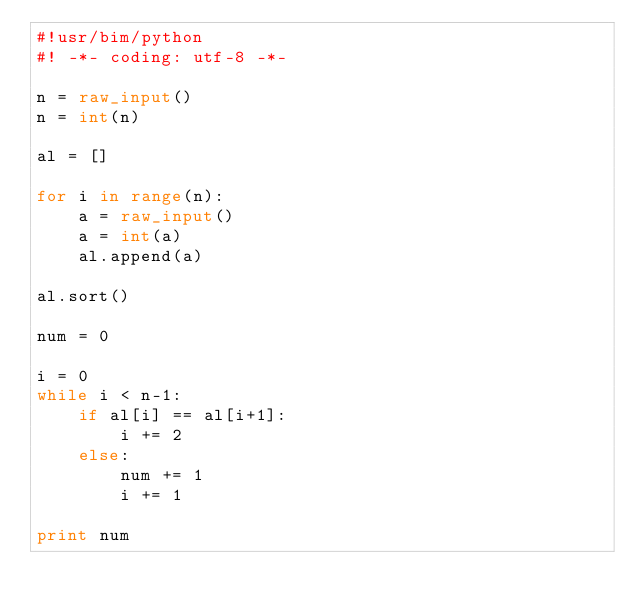Convert code to text. <code><loc_0><loc_0><loc_500><loc_500><_Python_>#!usr/bim/python
#! -*- coding: utf-8 -*-

n = raw_input()
n = int(n)

al = []

for i in range(n):
    a = raw_input()
    a = int(a)
    al.append(a)

al.sort()

num = 0

i = 0
while i < n-1:
    if al[i] == al[i+1]:
        i += 2
    else:
        num += 1
        i += 1

print num
</code> 